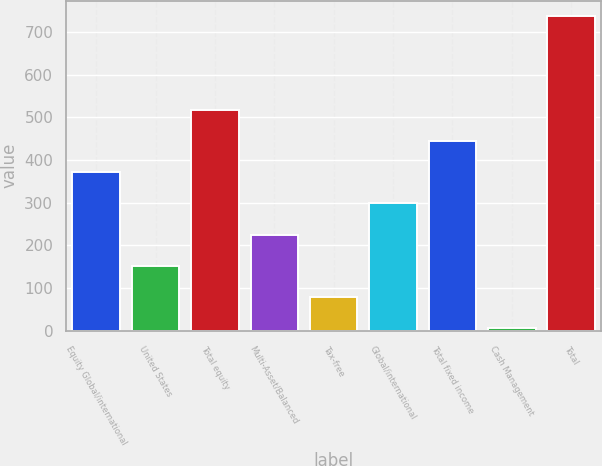Convert chart. <chart><loc_0><loc_0><loc_500><loc_500><bar_chart><fcel>Equity Global/international<fcel>United States<fcel>Total equity<fcel>Multi-Asset/Balanced<fcel>Tax-free<fcel>Global/international<fcel>Total fixed income<fcel>Cash Management<fcel>Total<nl><fcel>371.55<fcel>152.34<fcel>517.69<fcel>225.41<fcel>79.27<fcel>298.48<fcel>444.62<fcel>6.2<fcel>736.9<nl></chart> 